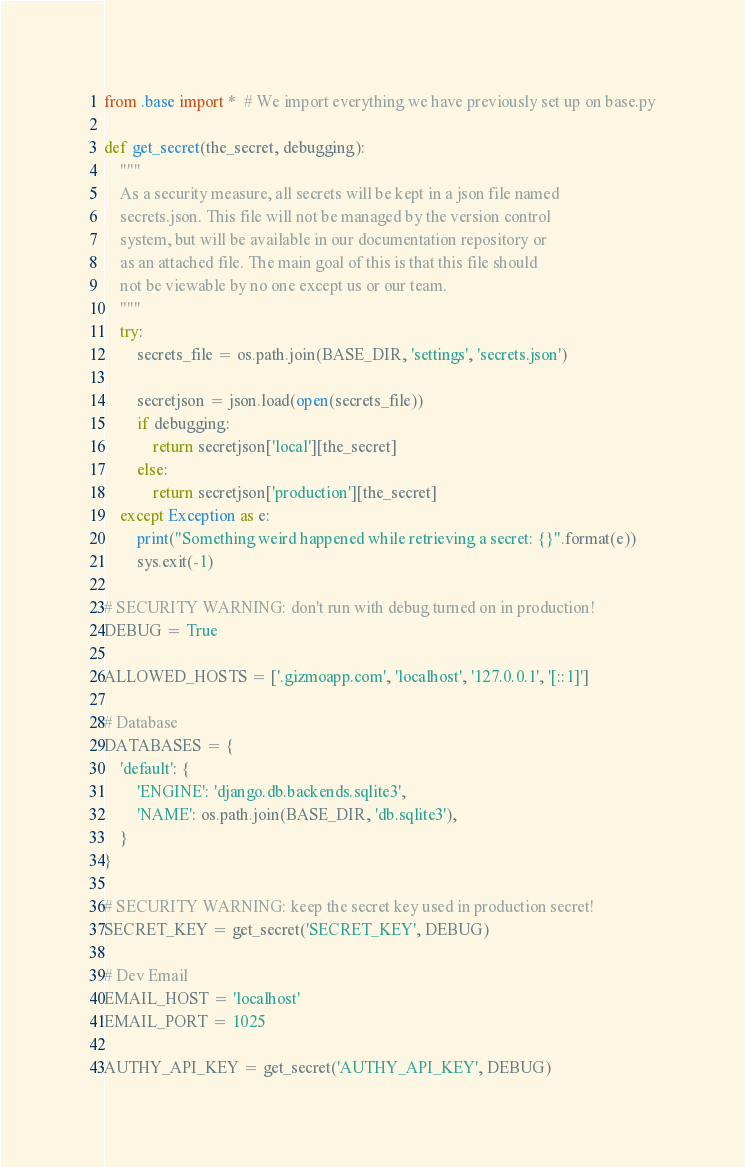<code> <loc_0><loc_0><loc_500><loc_500><_Python_>from .base import *  # We import everything we have previously set up on base.py
 
def get_secret(the_secret, debugging):
    """
    As a security measure, all secrets will be kept in a json file named
    secrets.json. This file will not be managed by the version control
    system, but will be available in our documentation repository or
    as an attached file. The main goal of this is that this file should
    not be viewable by no one except us or our team.
    """
    try:
        secrets_file = os.path.join(BASE_DIR, 'settings', 'secrets.json')

        secretjson = json.load(open(secrets_file))
        if debugging:
            return secretjson['local'][the_secret]
        else:
            return secretjson['production'][the_secret]
    except Exception as e:
        print("Something weird happened while retrieving a secret: {}".format(e))
        sys.exit(-1)
 
# SECURITY WARNING: don't run with debug turned on in production!
DEBUG = True
 
ALLOWED_HOSTS = ['.gizmoapp.com', 'localhost', '127.0.0.1', '[::1]'] 

# Database
DATABASES = {
    'default': {
        'ENGINE': 'django.db.backends.sqlite3',
        'NAME': os.path.join(BASE_DIR, 'db.sqlite3'),
    }
}
 
# SECURITY WARNING: keep the secret key used in production secret!
SECRET_KEY = get_secret('SECRET_KEY', DEBUG)

# Dev Email
EMAIL_HOST = 'localhost'
EMAIL_PORT = 1025

AUTHY_API_KEY = get_secret('AUTHY_API_KEY', DEBUG)
</code> 